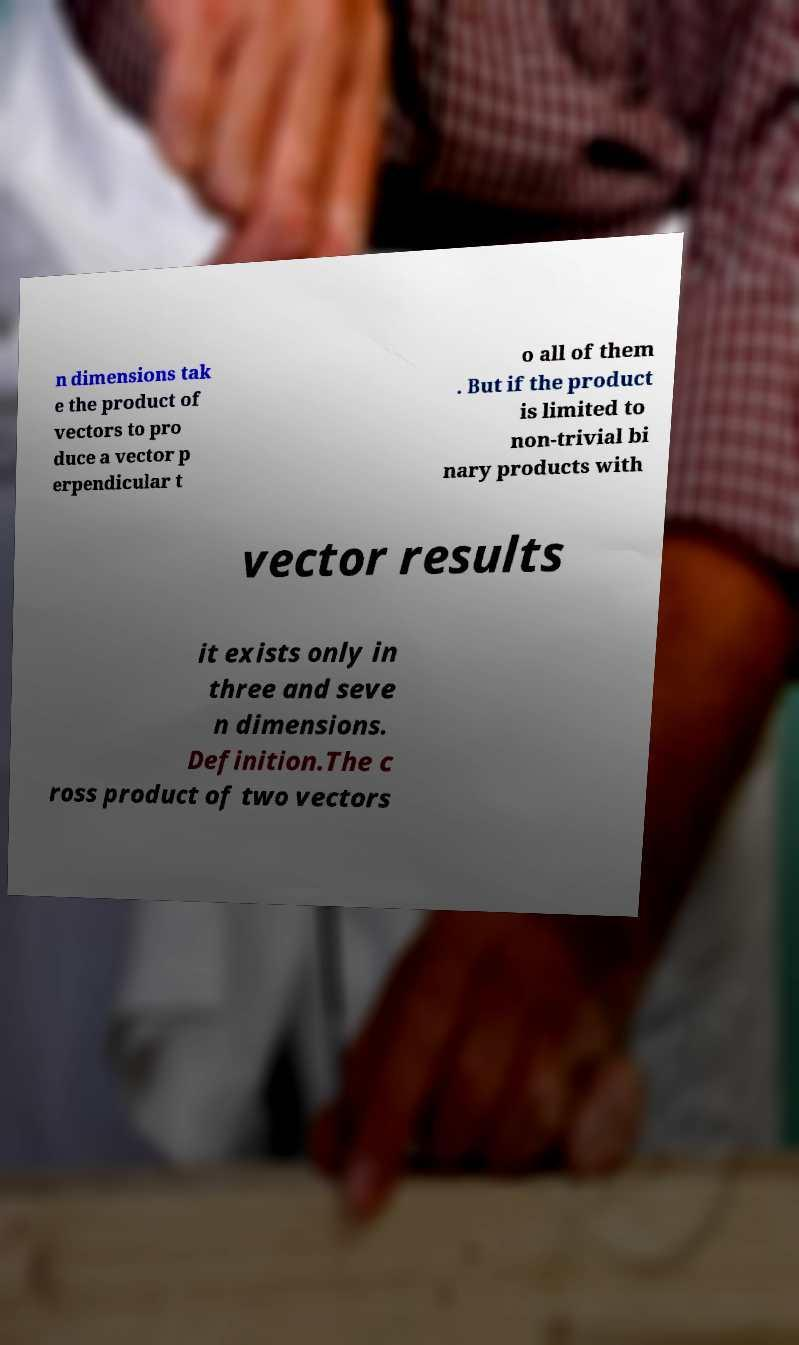Could you assist in decoding the text presented in this image and type it out clearly? n dimensions tak e the product of vectors to pro duce a vector p erpendicular t o all of them . But if the product is limited to non-trivial bi nary products with vector results it exists only in three and seve n dimensions. Definition.The c ross product of two vectors 